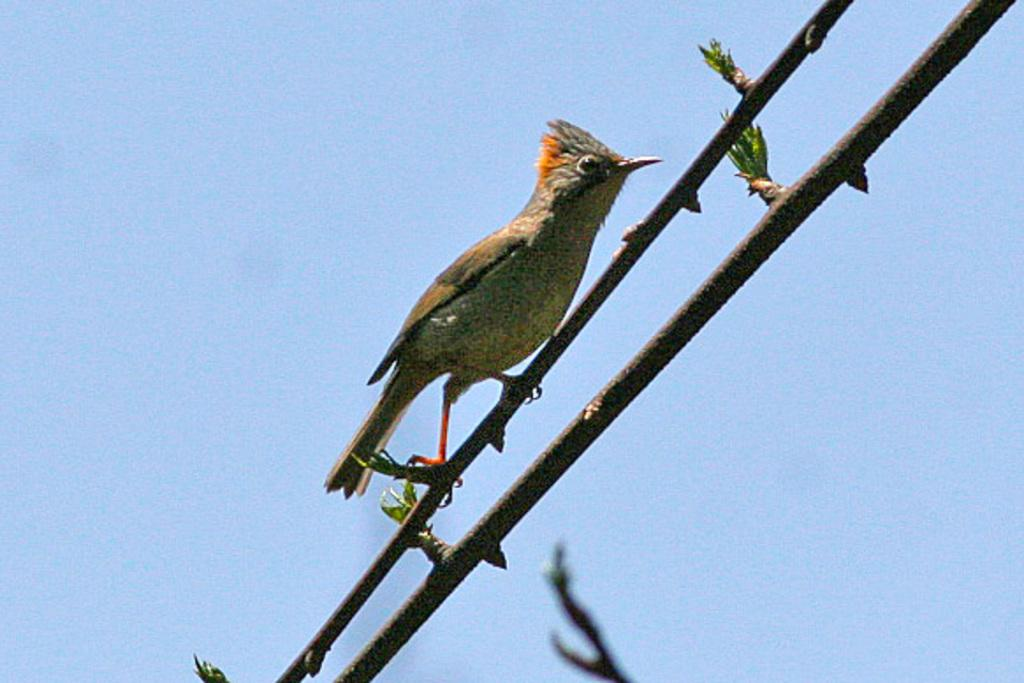What is the bird doing in the image? The bird is standing on the stem of a tree in the image. What can be seen in the background of the image? The sky is visible in the background of the image. What type of design can be seen on the bird's feathers in the image? There is no specific design mentioned on the bird's feathers in the provided facts, so it cannot be determined from the image. 